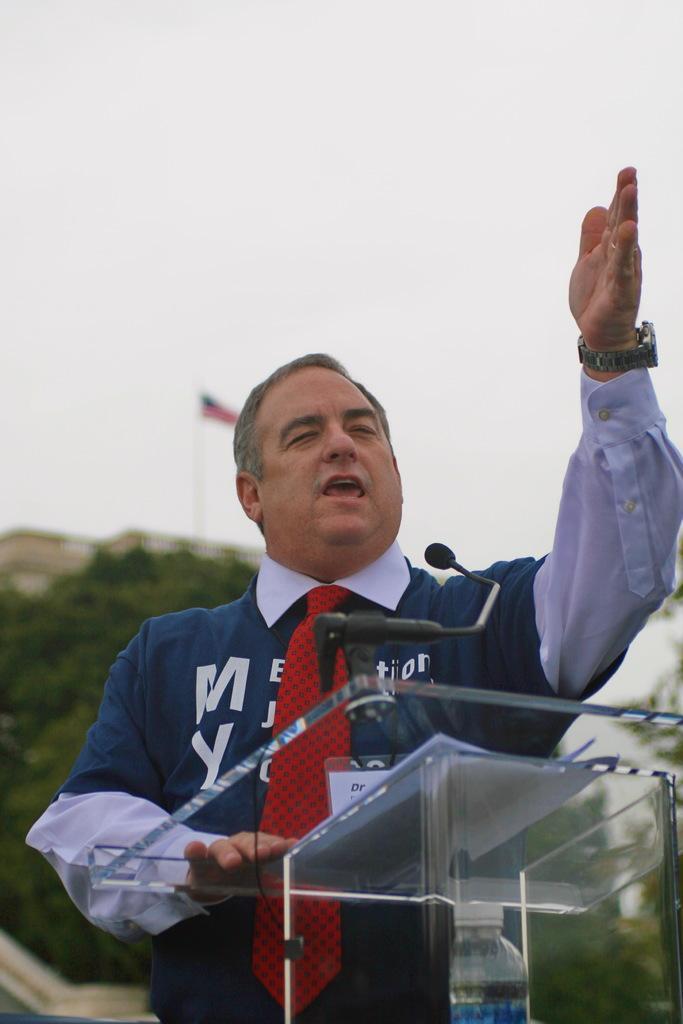Describe this image in one or two sentences. In the center of the image we can see one person is standing. In front of him, there is a glass stand, one water bottle, papers and one microphone. In the background we can see the sky, clouds, trees, one building, one flag etc. 